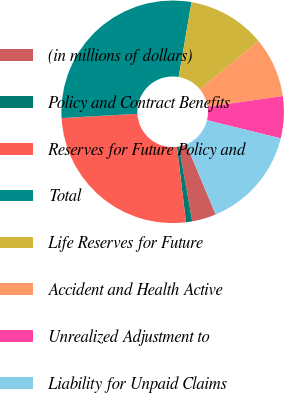Convert chart to OTSL. <chart><loc_0><loc_0><loc_500><loc_500><pie_chart><fcel>(in millions of dollars)<fcel>Policy and Contract Benefits<fcel>Reserves for Future Policy and<fcel>Total<fcel>Life Reserves for Future<fcel>Accident and Health Active<fcel>Unrealized Adjustment to<fcel>Liability for Unpaid Claims<nl><fcel>3.5%<fcel>0.9%<fcel>26.01%<fcel>28.61%<fcel>11.31%<fcel>8.71%<fcel>6.1%<fcel>14.85%<nl></chart> 